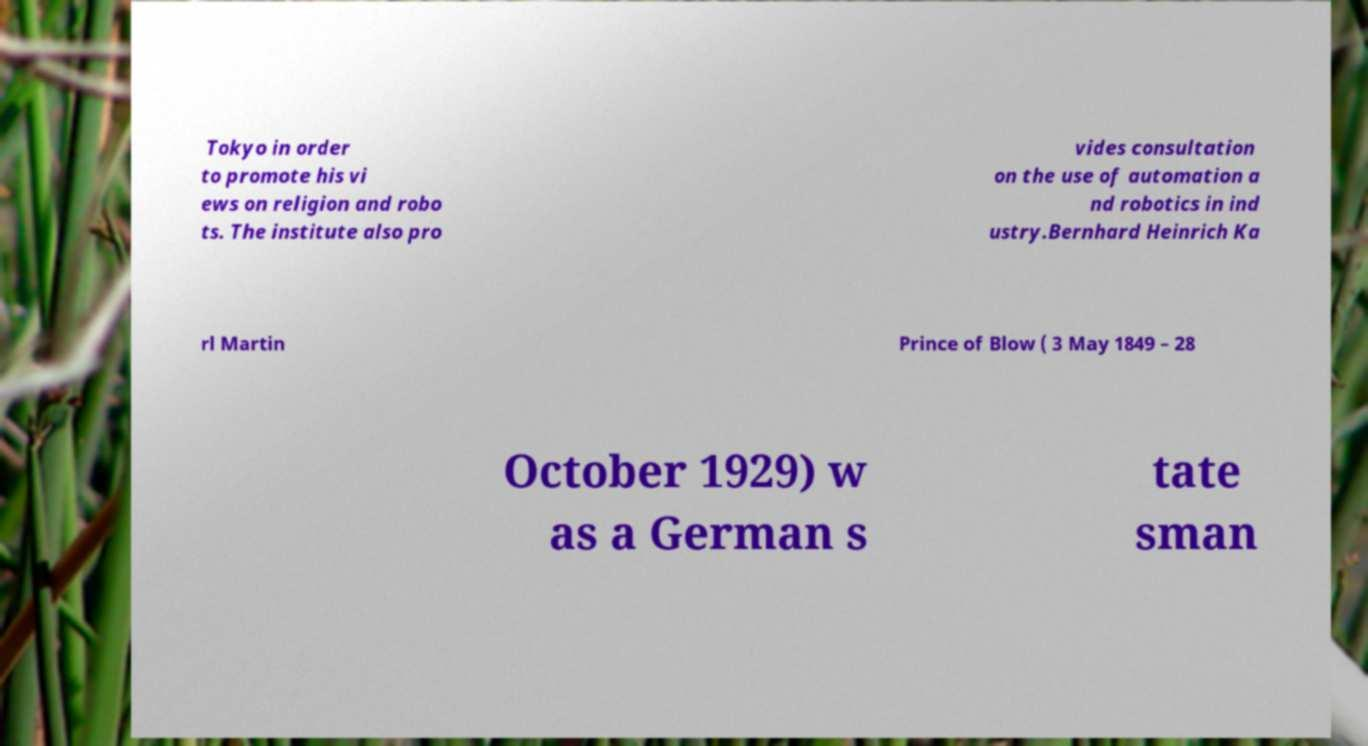Can you accurately transcribe the text from the provided image for me? Tokyo in order to promote his vi ews on religion and robo ts. The institute also pro vides consultation on the use of automation a nd robotics in ind ustry.Bernhard Heinrich Ka rl Martin Prince of Blow ( 3 May 1849 – 28 October 1929) w as a German s tate sman 